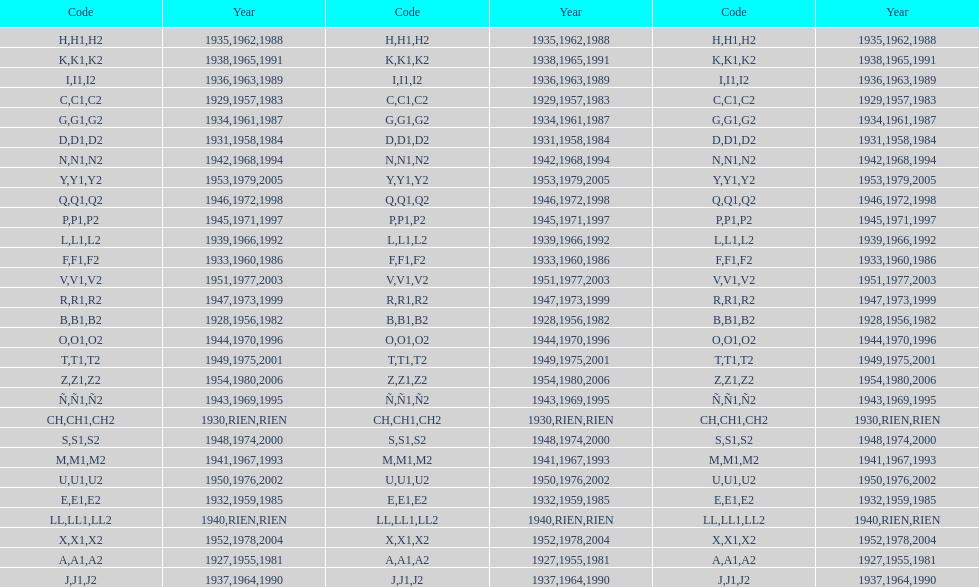Other than 1927 what year did the code start with a? 1955, 1981. 